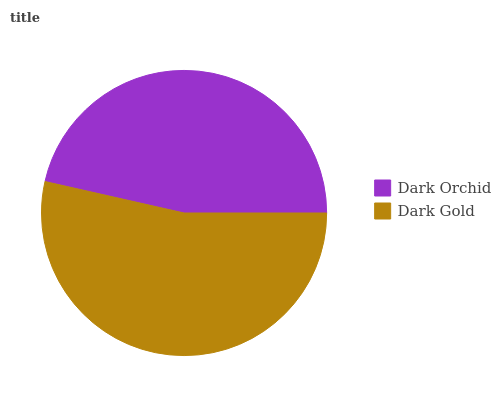Is Dark Orchid the minimum?
Answer yes or no. Yes. Is Dark Gold the maximum?
Answer yes or no. Yes. Is Dark Gold the minimum?
Answer yes or no. No. Is Dark Gold greater than Dark Orchid?
Answer yes or no. Yes. Is Dark Orchid less than Dark Gold?
Answer yes or no. Yes. Is Dark Orchid greater than Dark Gold?
Answer yes or no. No. Is Dark Gold less than Dark Orchid?
Answer yes or no. No. Is Dark Gold the high median?
Answer yes or no. Yes. Is Dark Orchid the low median?
Answer yes or no. Yes. Is Dark Orchid the high median?
Answer yes or no. No. Is Dark Gold the low median?
Answer yes or no. No. 